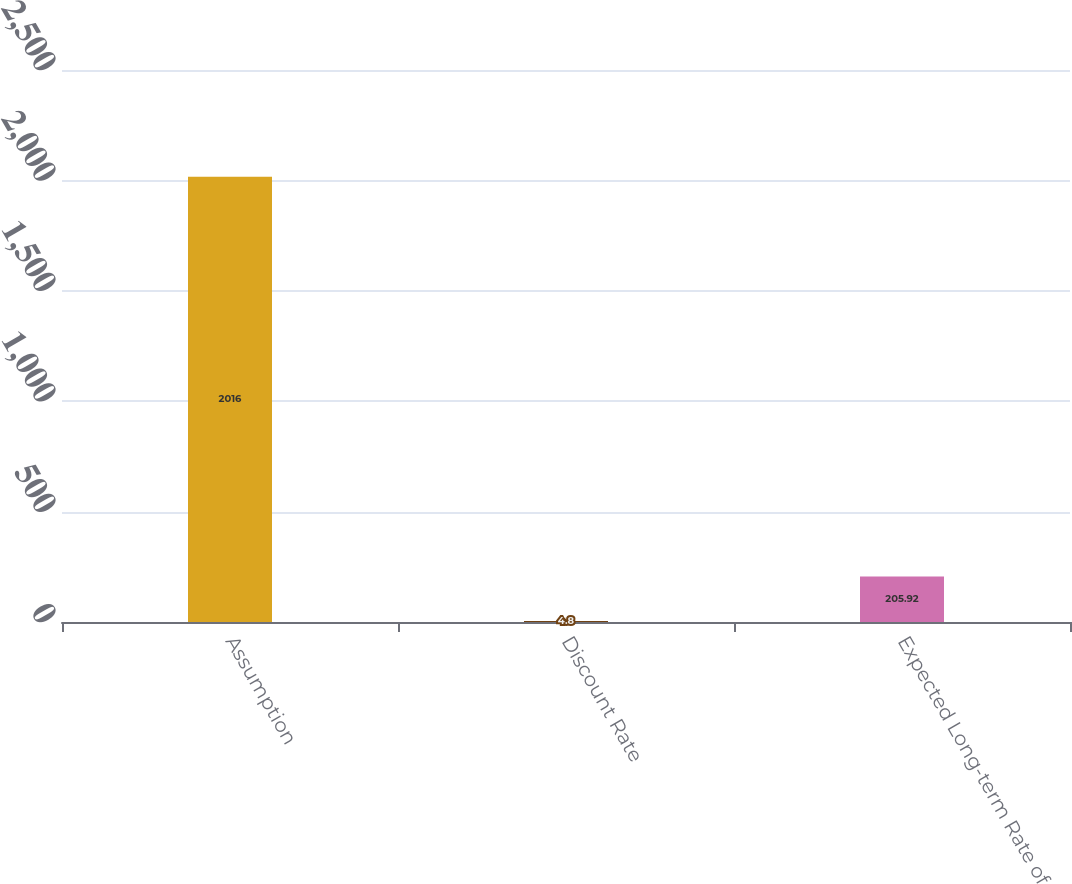Convert chart to OTSL. <chart><loc_0><loc_0><loc_500><loc_500><bar_chart><fcel>Assumption<fcel>Discount Rate<fcel>Expected Long-term Rate of<nl><fcel>2016<fcel>4.8<fcel>205.92<nl></chart> 